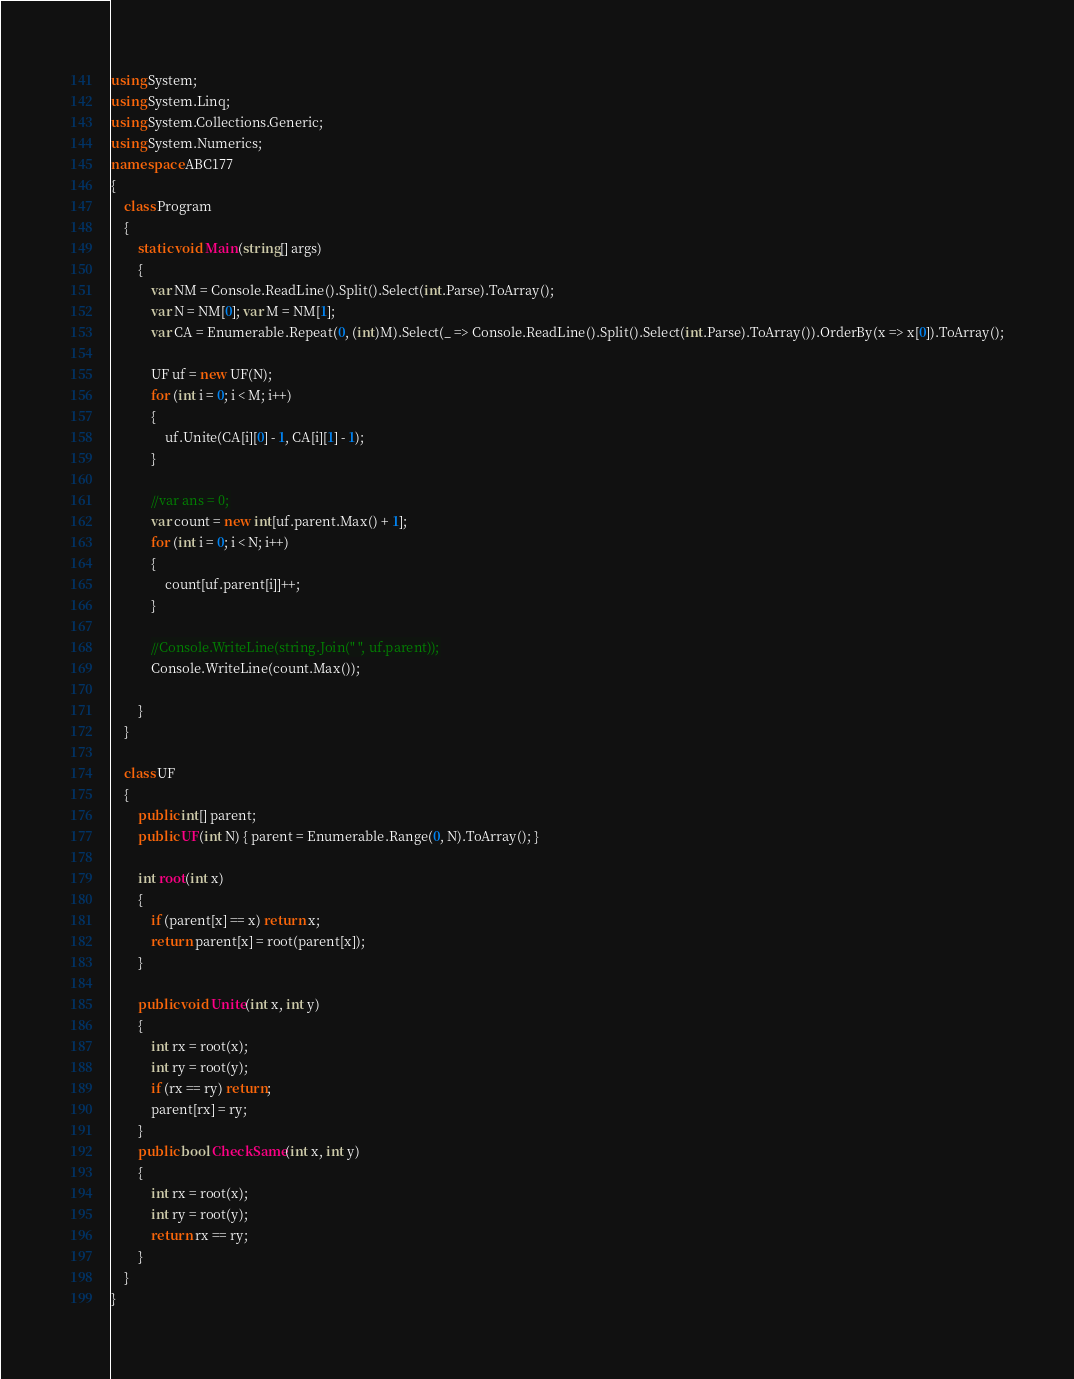<code> <loc_0><loc_0><loc_500><loc_500><_C#_>
using System;
using System.Linq;
using System.Collections.Generic;
using System.Numerics;
namespace ABC177
{
    class Program
    {
        static void Main(string[] args)
        {
            var NM = Console.ReadLine().Split().Select(int.Parse).ToArray();
            var N = NM[0]; var M = NM[1];
            var CA = Enumerable.Repeat(0, (int)M).Select(_ => Console.ReadLine().Split().Select(int.Parse).ToArray()).OrderBy(x => x[0]).ToArray();

            UF uf = new UF(N);
            for (int i = 0; i < M; i++)
            {
                uf.Unite(CA[i][0] - 1, CA[i][1] - 1);
            }

            //var ans = 0;
            var count = new int[uf.parent.Max() + 1];
            for (int i = 0; i < N; i++)
            {
                count[uf.parent[i]]++;
            }

            //Console.WriteLine(string.Join(" ", uf.parent));
            Console.WriteLine(count.Max());

        }
    }

    class UF
    {
        public int[] parent;
        public UF(int N) { parent = Enumerable.Range(0, N).ToArray(); }

        int root(int x)
        {
            if (parent[x] == x) return x;
            return parent[x] = root(parent[x]);
        }

        public void Unite(int x, int y)
        {
            int rx = root(x);
            int ry = root(y);
            if (rx == ry) return;
            parent[rx] = ry;
        }
        public bool CheckSame(int x, int y)
        {
            int rx = root(x);
            int ry = root(y);
            return rx == ry;
        }
    }
}</code> 